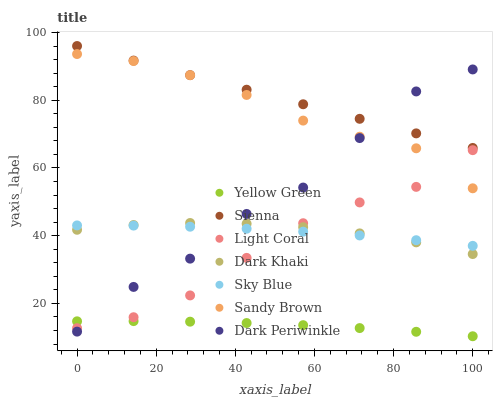Does Yellow Green have the minimum area under the curve?
Answer yes or no. Yes. Does Sienna have the maximum area under the curve?
Answer yes or no. Yes. Does Sienna have the minimum area under the curve?
Answer yes or no. No. Does Yellow Green have the maximum area under the curve?
Answer yes or no. No. Is Sienna the smoothest?
Answer yes or no. Yes. Is Dark Periwinkle the roughest?
Answer yes or no. Yes. Is Yellow Green the smoothest?
Answer yes or no. No. Is Yellow Green the roughest?
Answer yes or no. No. Does Yellow Green have the lowest value?
Answer yes or no. Yes. Does Sienna have the lowest value?
Answer yes or no. No. Does Sienna have the highest value?
Answer yes or no. Yes. Does Yellow Green have the highest value?
Answer yes or no. No. Is Light Coral less than Sienna?
Answer yes or no. Yes. Is Sienna greater than Yellow Green?
Answer yes or no. Yes. Does Sky Blue intersect Dark Periwinkle?
Answer yes or no. Yes. Is Sky Blue less than Dark Periwinkle?
Answer yes or no. No. Is Sky Blue greater than Dark Periwinkle?
Answer yes or no. No. Does Light Coral intersect Sienna?
Answer yes or no. No. 